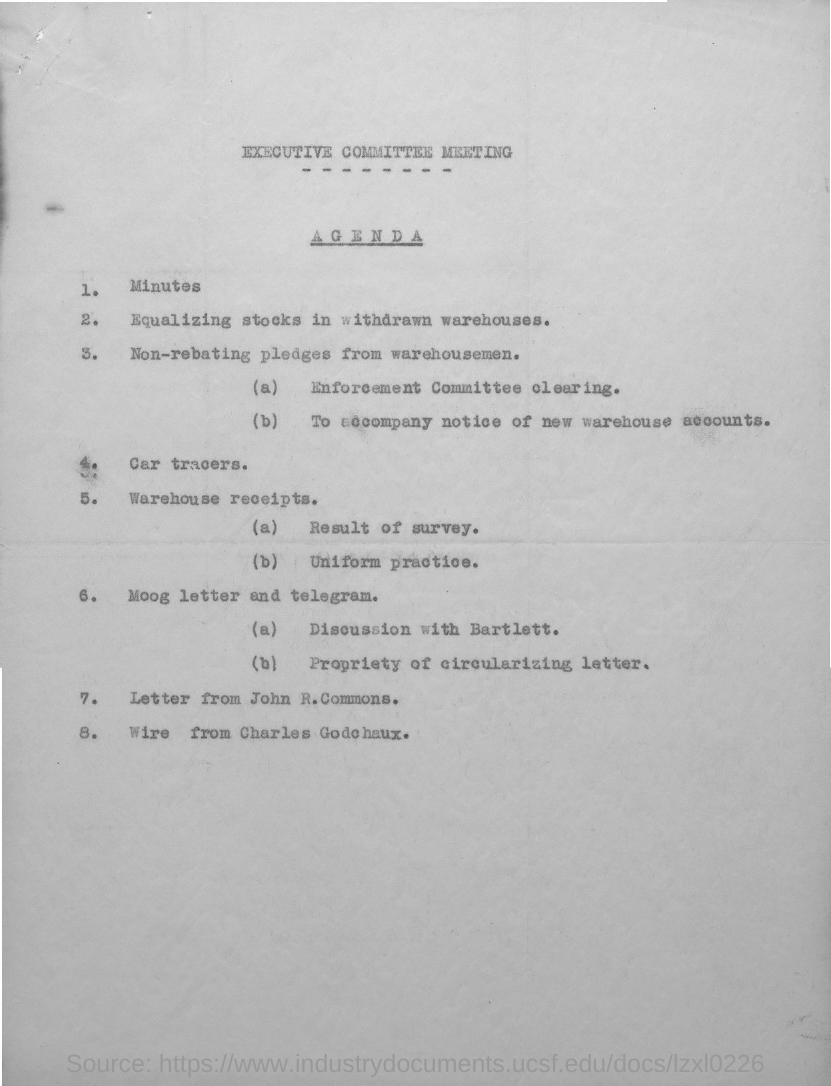Indicate a few pertinent items in this graphic. Agenda item number 4 is 'Car Trackers.' The second title in the document is 'Agenda'. What is agenda number 1? Minutes.." is a question asking for information about a specific topic. The first title in the document is 'Executive Committee Meeting.' Agenda number 7 refers to a letter written by John R. Commons to the President of the United States, outlining the need for a national policy on labor disputes. 